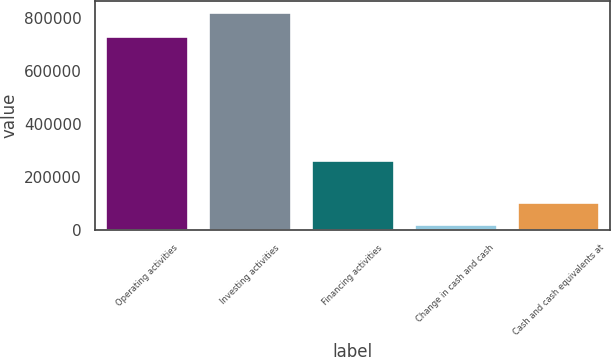Convert chart to OTSL. <chart><loc_0><loc_0><loc_500><loc_500><bar_chart><fcel>Operating activities<fcel>Investing activities<fcel>Financing activities<fcel>Change in cash and cash<fcel>Cash and cash equivalents at<nl><fcel>732813<fcel>824979<fcel>264252<fcel>23941<fcel>104045<nl></chart> 